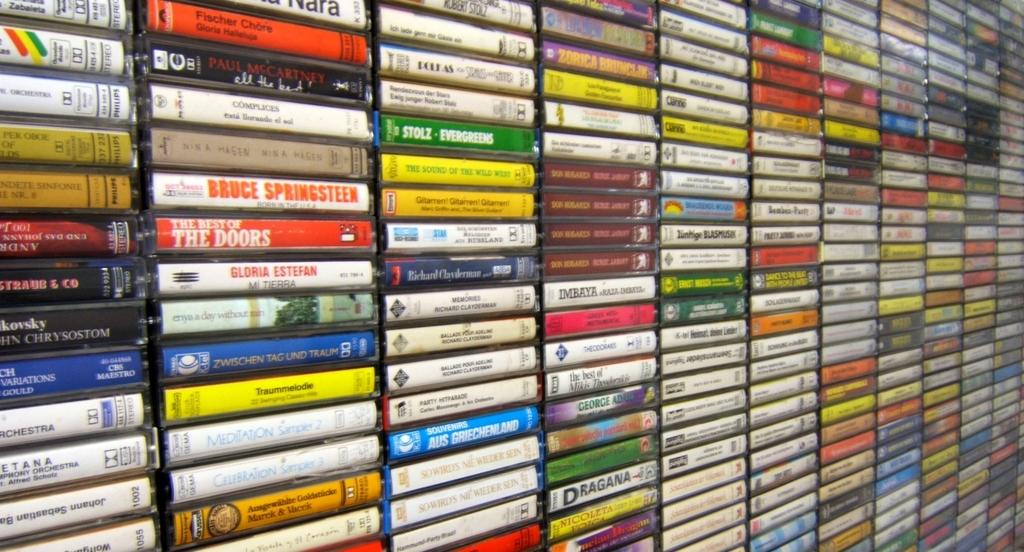<image>
Present a compact description of the photo's key features. A wall of stacked music CD's including one by Bruce Springsteen. 